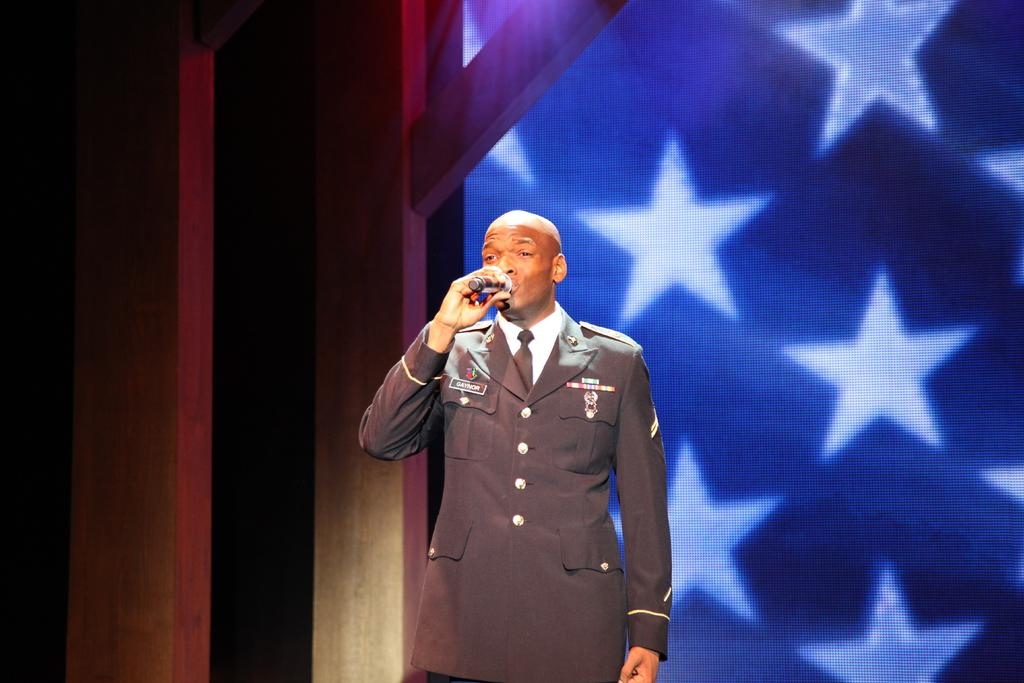Who is the main subject in the image? There is a man in the image. What is the man holding in the image? The man is holding a microphone. What can be seen behind the man in the image? There is a screen visible behind the man. What route is the man taking with the yoke in the image? There is no yoke present in the image, and the man is not taking any route; he is holding a microphone. 